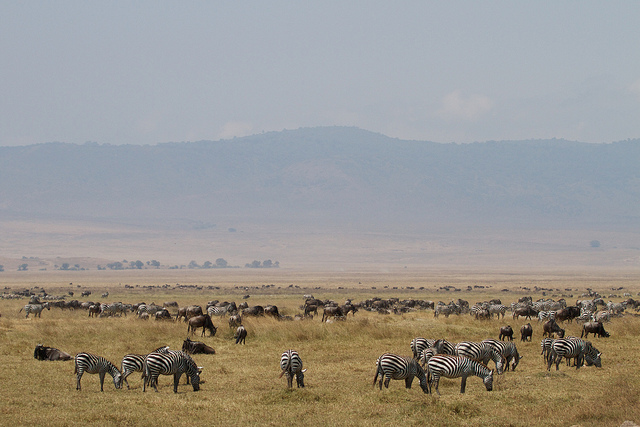<image>What is the website on the photo? It's unknown what website is on the photo as it's not visible. What is the website on the photo? I am not sure what website is on the photo. It is not mentioned or visible. 